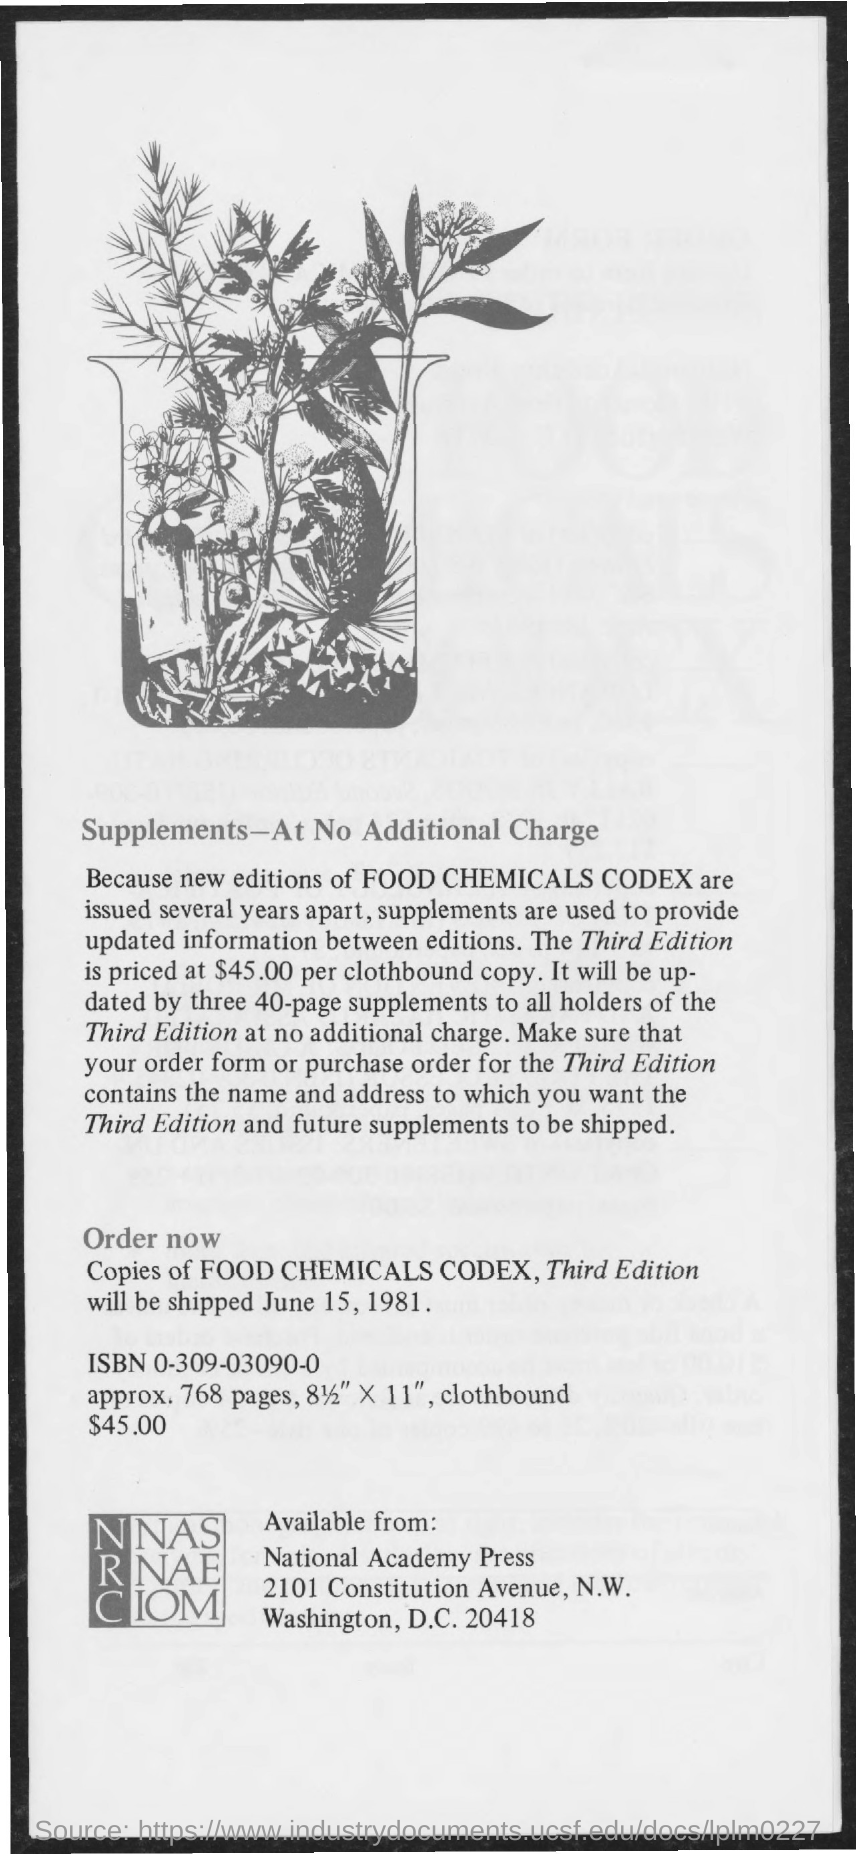List a handful of essential elements in this visual. The date on which the shipment is expected to be sent is June 15, 1981. The third edition of the book is priced at $45.00 per clothbound copy. 